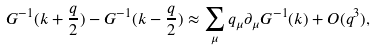<formula> <loc_0><loc_0><loc_500><loc_500>G ^ { - 1 } ( k + \frac { q } { 2 } ) - G ^ { - 1 } ( k - \frac { q } { 2 } ) \approx \sum _ { \mu } q _ { \mu } \partial _ { \mu } G ^ { - 1 } ( k ) + O ( q ^ { 3 } ) ,</formula> 